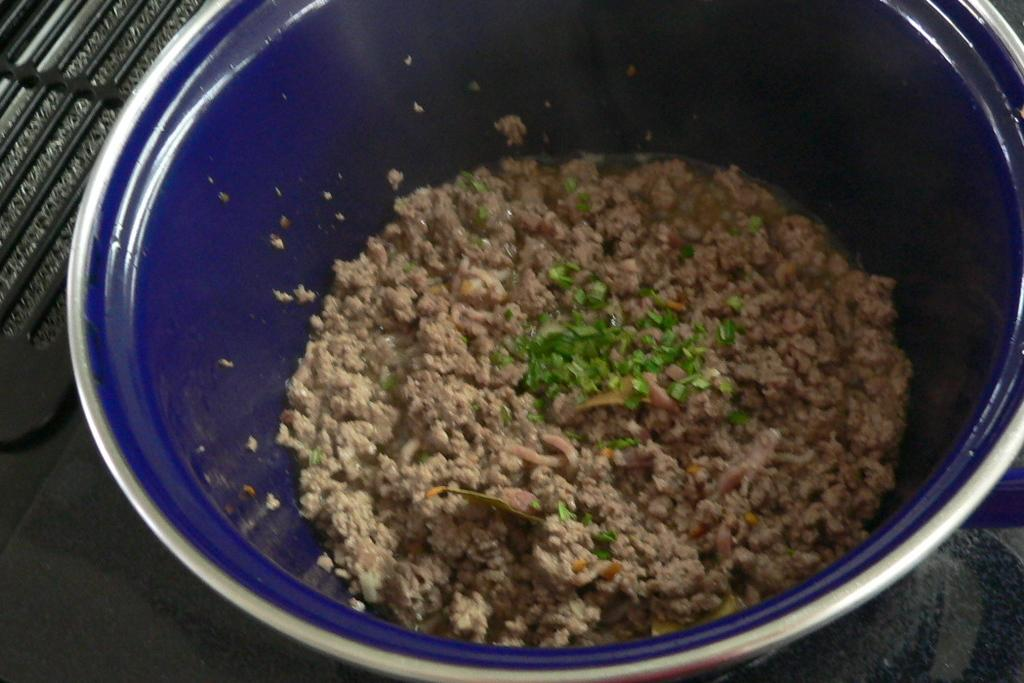What is the main subject of the image? The main subject of the image is food. How is the food presented in the image? The food is placed in a blue bowl. What day of the week is depicted in the image? The image does not depict a specific day of the week; it only shows food in a blue bowl. Can you see a hand holding the blue bowl in the image? There is no hand visible in the image; it only shows the food in the blue bowl. 